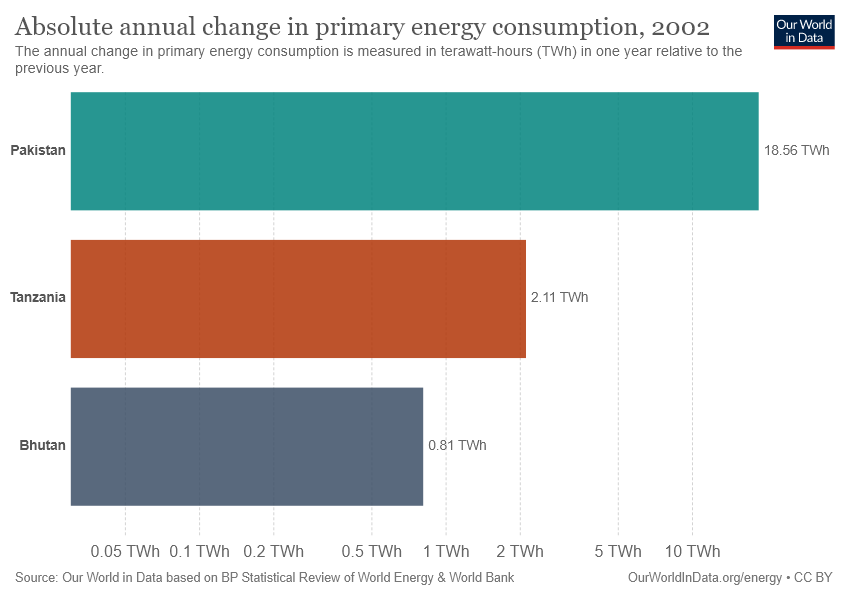Draw attention to some important aspects in this diagram. The difference in the value of the largest two bars is not double the value of the smallest bar. Pakistan is the largest bar country in the world. 